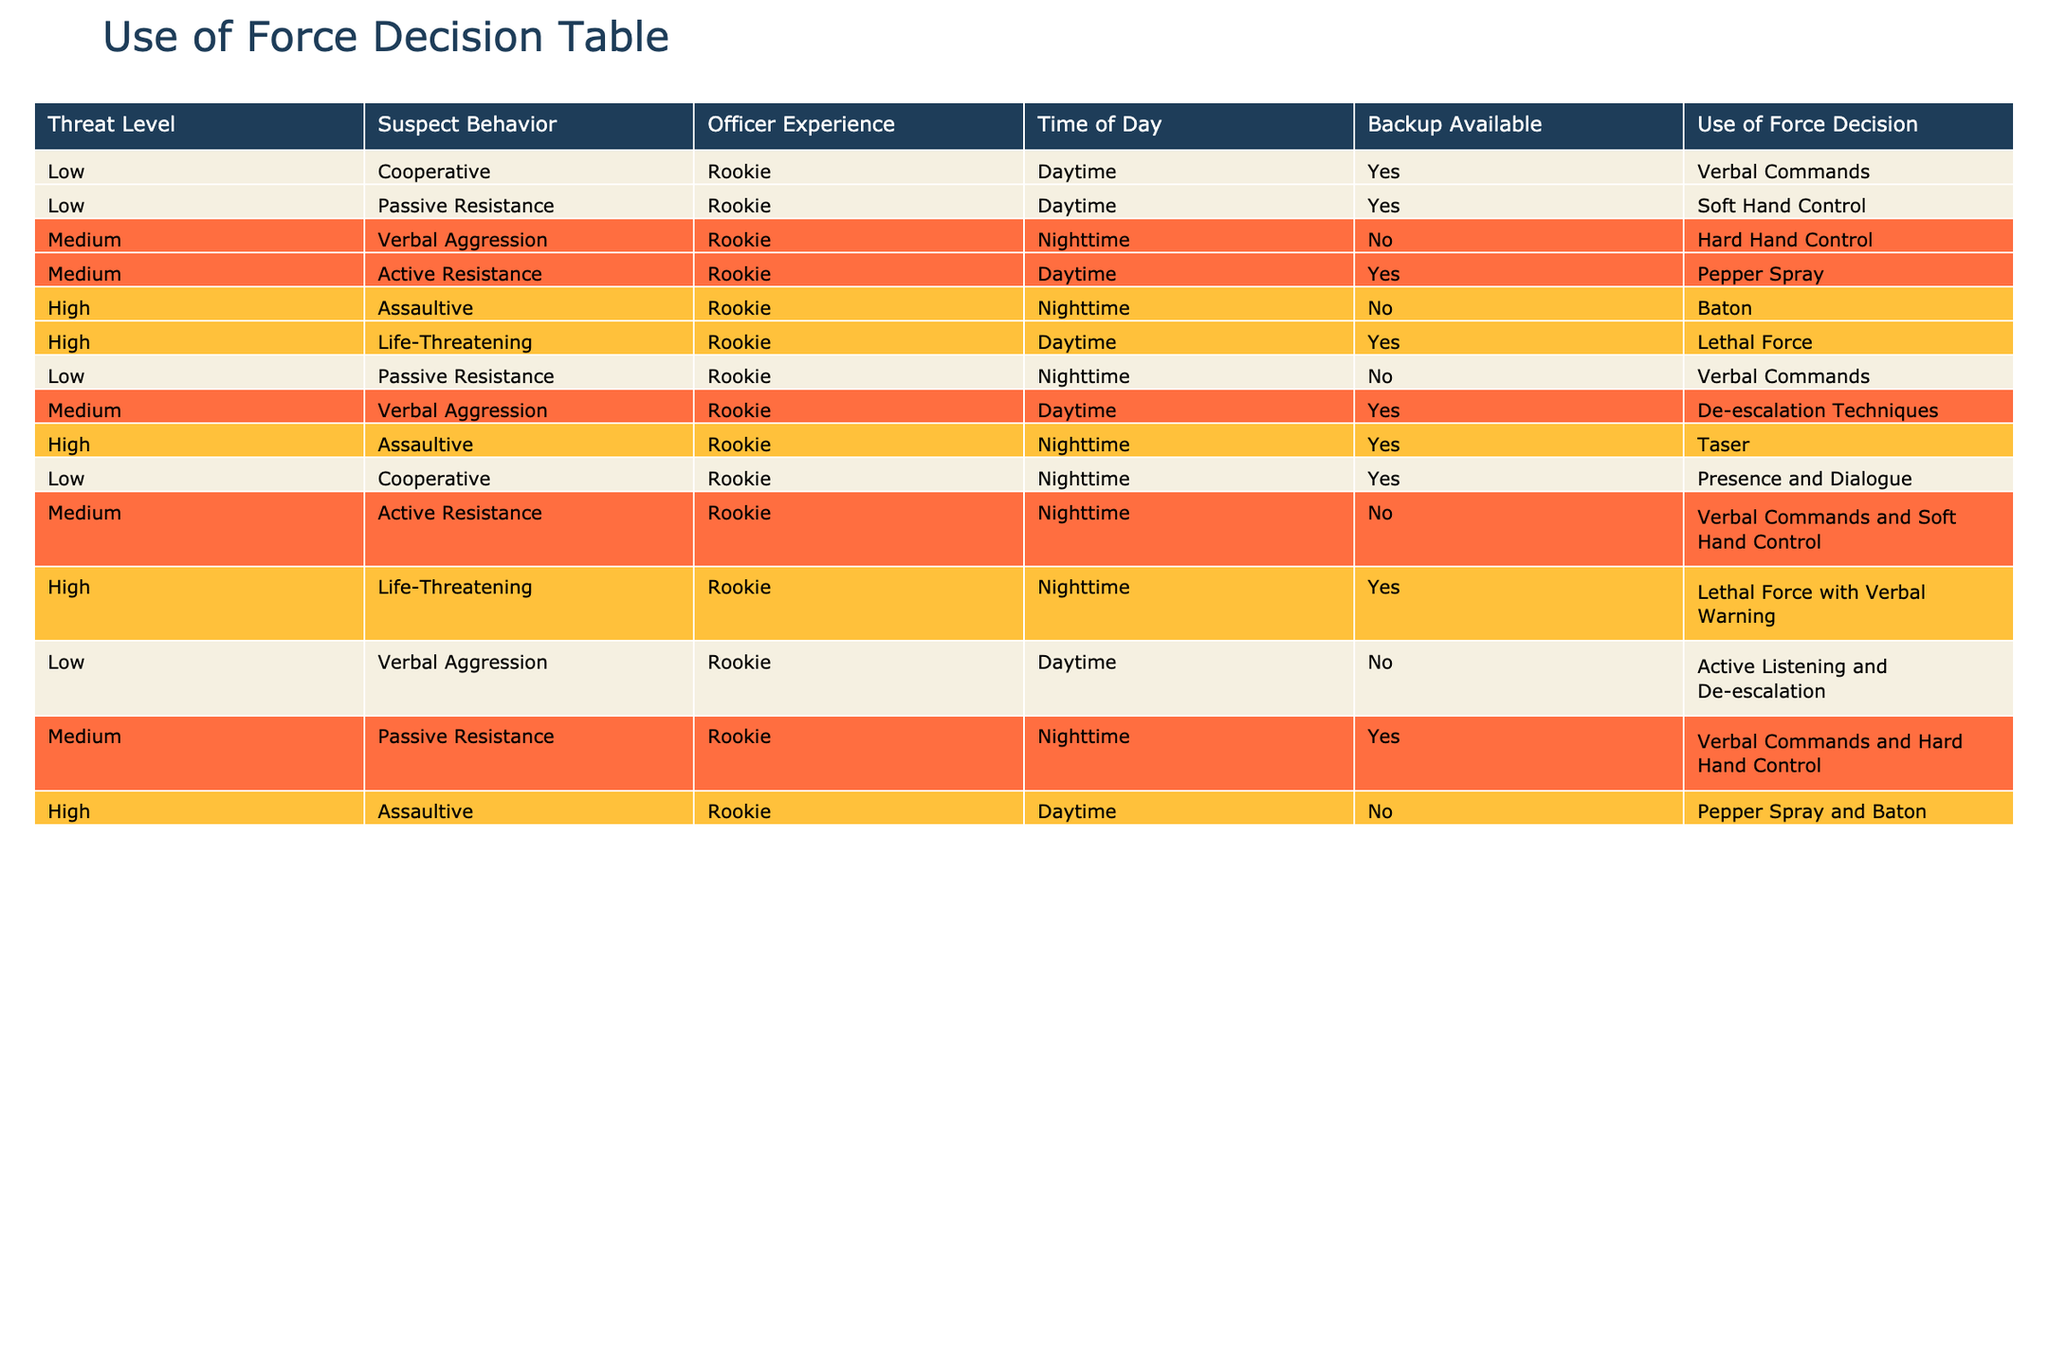What use of force decision is applied for a low-threat level with passive resistance during the daytime when backup is available? In the table, we look for the row where the threat level is "Low," the suspect behavior is "Passive Resistance," the officer experience is "Rookie," the time of day is "Daytime," and backup is available. There is one matching row, which indicates that the use of force decision is "Soft Hand Control."
Answer: Soft Hand Control Is lethal force used when the suspect behavior is life-threatening during the daytime with backup available? The table has a row with a "High" threat level where the behavior is "Life-Threatening," the time is "Daytime," and backup is "Yes." It states that the use of force decision is "Lethal Force." Thus, lethal force is indeed used in this situation.
Answer: Yes How many instances are there of using verbal commands as a decision for a low-threat level? We count the rows where the threat level is "Low" and the use of force decision is "Verbal Commands." There are two such instances (one during the daytime and one during the nighttime), so the total is 2.
Answer: 2 What is the average level of threat for all scenarios where the officer's experience is rookie? The threat levels in the rows for rookies are Low, Medium, High, and they appear multiple times. To calculate the average, we can assign numerical values (Low=1, Medium=2, High=3) and compute their occurrences, then find the average: (1*6 + 2*7 + 3*5) / 18 = 2. Both low and medium levels have more occurrences than high, which contributes to an average level leaning towards medium.
Answer: 2 If a suspect is exhibiting active resistance at nighttime and no backup is available, what should the officer do? Referring to the table, we find the row with "Active Resistance," "Nighttime," and "No" backup. The stored decision here indicates the response should be "Verbal Commands and Soft Hand Control." This represents a less forceful response given the conditions.
Answer: Verbal Commands and Soft Hand Control Is it true that when backup is available at nighttime, no use of lethal force decisions are made? To check this, we look through all nighttime scenarios where backup is available and any use of force involving lethal actions. The table shows that for "Life-Threatening" conditions at night with backup, "Lethal Force with Verbal Warning" is present. Therefore, this statement is false.
Answer: No What is the total number of distinct responses available for medium-level threats involving rookies? Analyzing the rows where the threat level is "Medium," we find three distinct responses: "Verbal Aggression," "Active Resistance," and "Passive Resistance." Summarizing these unique responses, the total is 3.
Answer: 3 When is taser usage permitted according to the table? We look for rows regarding taser use in the table. The relevant entry is under "High" threat level, "Assaultive" behavior, "Nighttime" with backup being available. The decision states that taser is an option in this scenario.
Answer: High threat level, Assaultive behavior, Nighttime with backup available 